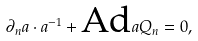Convert formula to latex. <formula><loc_0><loc_0><loc_500><loc_500>\partial _ { n } a \cdot a ^ { - 1 } + \text {Ad} a Q _ { n } = 0 ,</formula> 